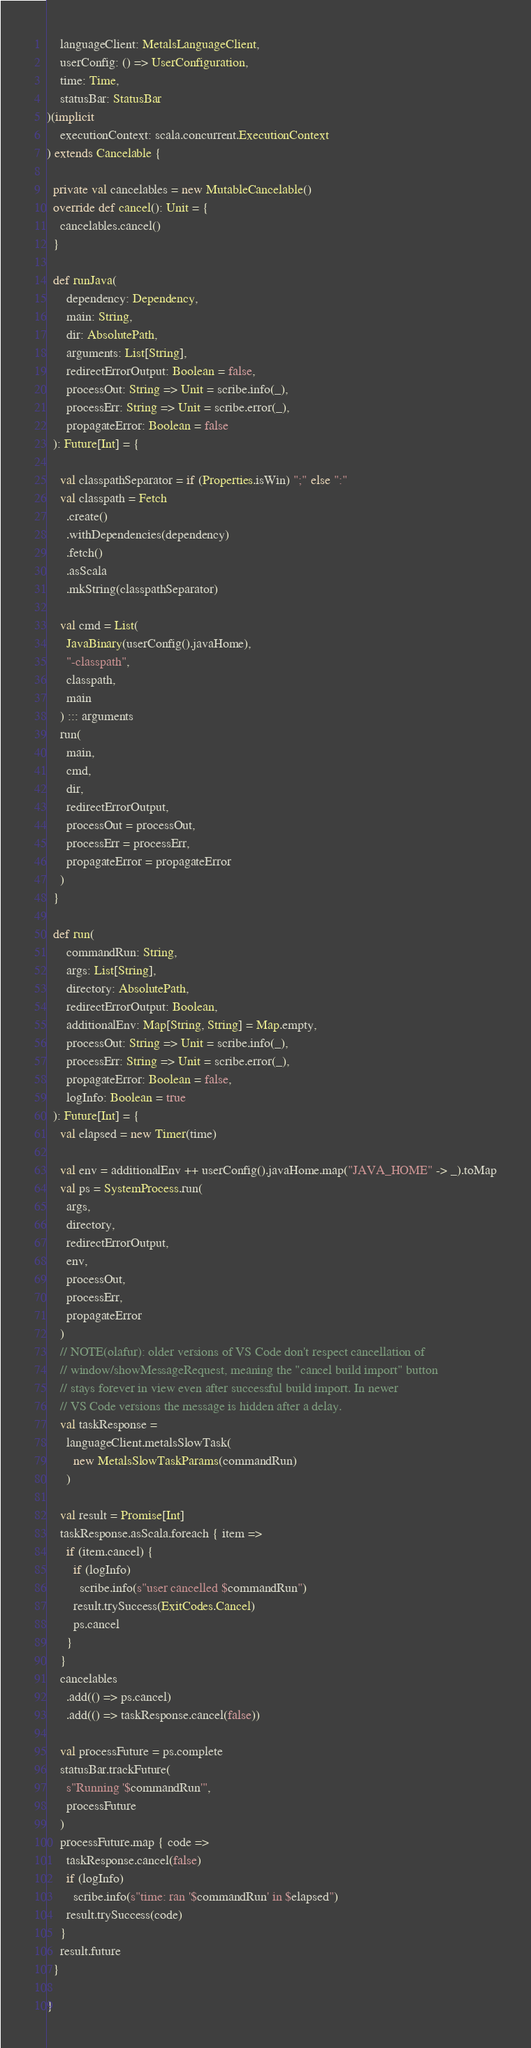<code> <loc_0><loc_0><loc_500><loc_500><_Scala_>    languageClient: MetalsLanguageClient,
    userConfig: () => UserConfiguration,
    time: Time,
    statusBar: StatusBar
)(implicit
    executionContext: scala.concurrent.ExecutionContext
) extends Cancelable {

  private val cancelables = new MutableCancelable()
  override def cancel(): Unit = {
    cancelables.cancel()
  }

  def runJava(
      dependency: Dependency,
      main: String,
      dir: AbsolutePath,
      arguments: List[String],
      redirectErrorOutput: Boolean = false,
      processOut: String => Unit = scribe.info(_),
      processErr: String => Unit = scribe.error(_),
      propagateError: Boolean = false
  ): Future[Int] = {

    val classpathSeparator = if (Properties.isWin) ";" else ":"
    val classpath = Fetch
      .create()
      .withDependencies(dependency)
      .fetch()
      .asScala
      .mkString(classpathSeparator)

    val cmd = List(
      JavaBinary(userConfig().javaHome),
      "-classpath",
      classpath,
      main
    ) ::: arguments
    run(
      main,
      cmd,
      dir,
      redirectErrorOutput,
      processOut = processOut,
      processErr = processErr,
      propagateError = propagateError
    )
  }

  def run(
      commandRun: String,
      args: List[String],
      directory: AbsolutePath,
      redirectErrorOutput: Boolean,
      additionalEnv: Map[String, String] = Map.empty,
      processOut: String => Unit = scribe.info(_),
      processErr: String => Unit = scribe.error(_),
      propagateError: Boolean = false,
      logInfo: Boolean = true
  ): Future[Int] = {
    val elapsed = new Timer(time)

    val env = additionalEnv ++ userConfig().javaHome.map("JAVA_HOME" -> _).toMap
    val ps = SystemProcess.run(
      args,
      directory,
      redirectErrorOutput,
      env,
      processOut,
      processErr,
      propagateError
    )
    // NOTE(olafur): older versions of VS Code don't respect cancellation of
    // window/showMessageRequest, meaning the "cancel build import" button
    // stays forever in view even after successful build import. In newer
    // VS Code versions the message is hidden after a delay.
    val taskResponse =
      languageClient.metalsSlowTask(
        new MetalsSlowTaskParams(commandRun)
      )

    val result = Promise[Int]
    taskResponse.asScala.foreach { item =>
      if (item.cancel) {
        if (logInfo)
          scribe.info(s"user cancelled $commandRun")
        result.trySuccess(ExitCodes.Cancel)
        ps.cancel
      }
    }
    cancelables
      .add(() => ps.cancel)
      .add(() => taskResponse.cancel(false))

    val processFuture = ps.complete
    statusBar.trackFuture(
      s"Running '$commandRun'",
      processFuture
    )
    processFuture.map { code =>
      taskResponse.cancel(false)
      if (logInfo)
        scribe.info(s"time: ran '$commandRun' in $elapsed")
      result.trySuccess(code)
    }
    result.future
  }

}
</code> 